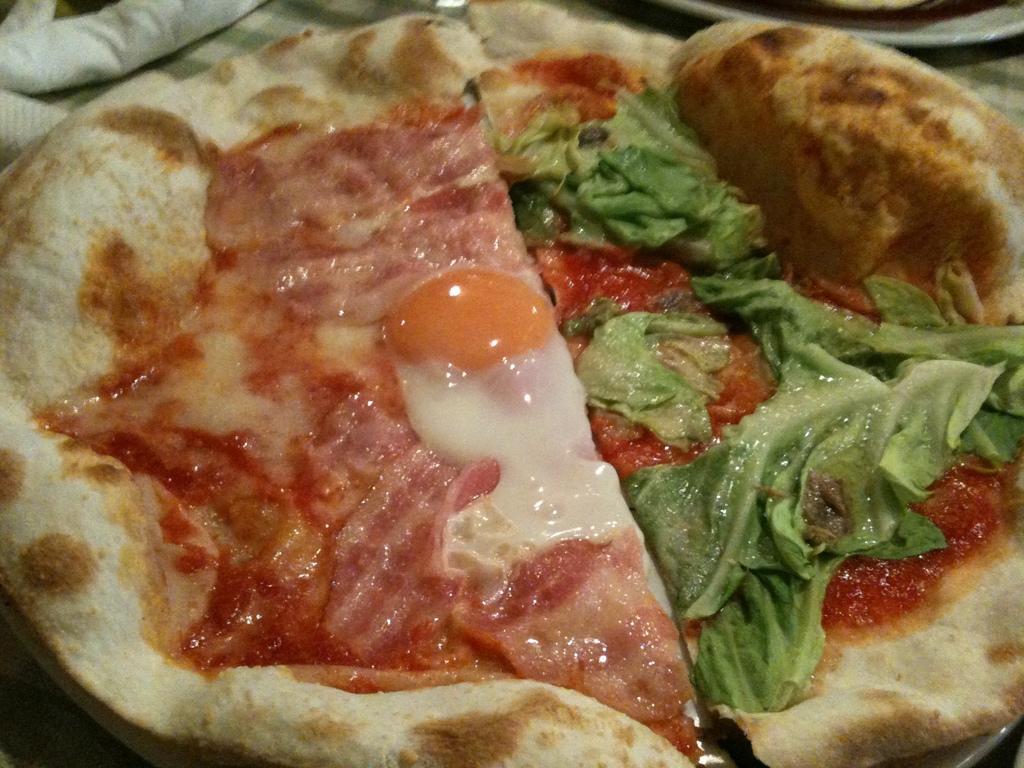In one or two sentences, can you explain what this image depicts? In the center of the image we can see a pizza. In the background there is a cloth and a plate. 